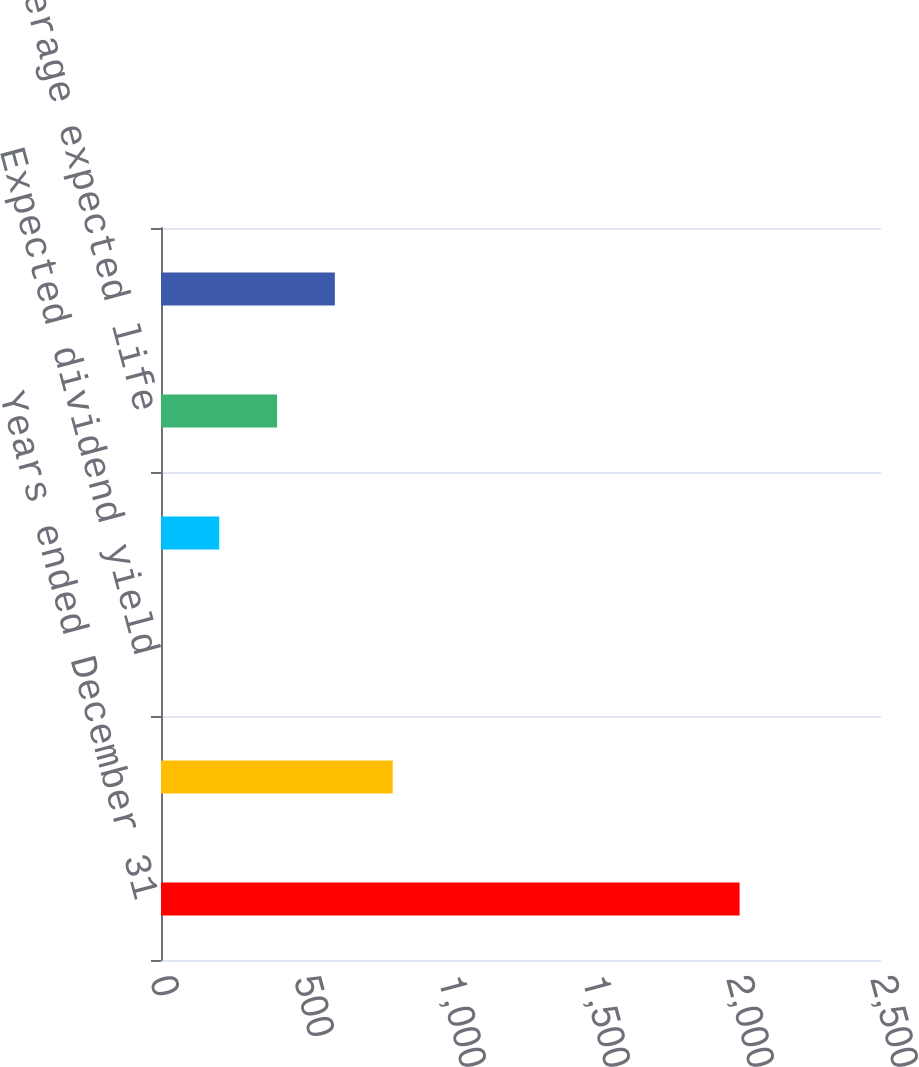Convert chart. <chart><loc_0><loc_0><loc_500><loc_500><bar_chart><fcel>Years ended December 31<fcel>Weighted average volatility<fcel>Expected dividend yield<fcel>Risk-free rate<fcel>Weighted average expected life<fcel>Weighted average estimated<nl><fcel>2009<fcel>804.5<fcel>1.5<fcel>202.25<fcel>403<fcel>603.75<nl></chart> 